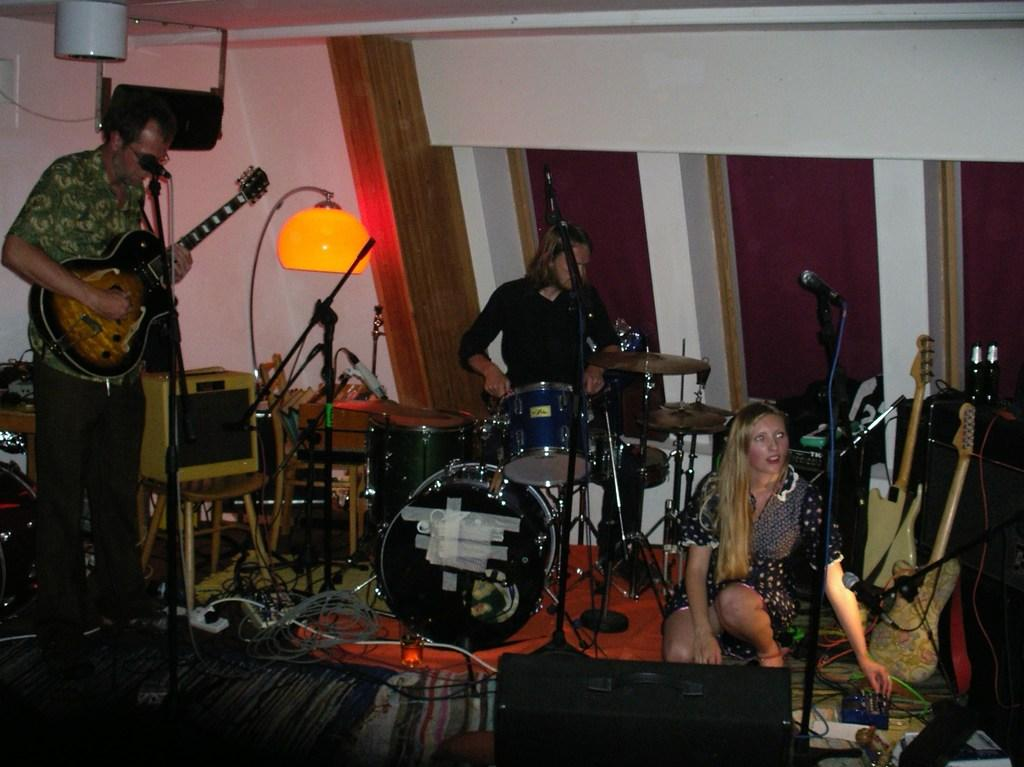How many people are in the image? There are three persons in the image. What are the persons doing in the image? The persons are playing musical instruments. Can you name any of the instruments being played? One of the instruments is a guitar, and another is a drum. What can be seen in the background of the image? There is a red color wall and a lamp in the background. Are the three persons in the image brothers? There is no information provided about the relationship between the three persons in the image, so we cannot determine if they are brothers. Can you see any magic happening in the image? There is no mention of magic or any magical elements in the image. 